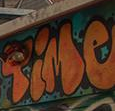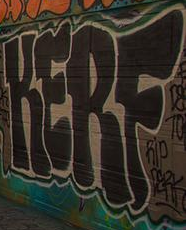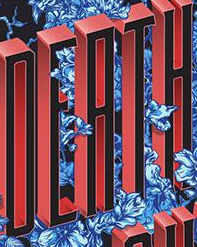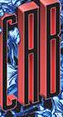What text appears in these images from left to right, separated by a semicolon? Time; KERF; DEATH; CAB 